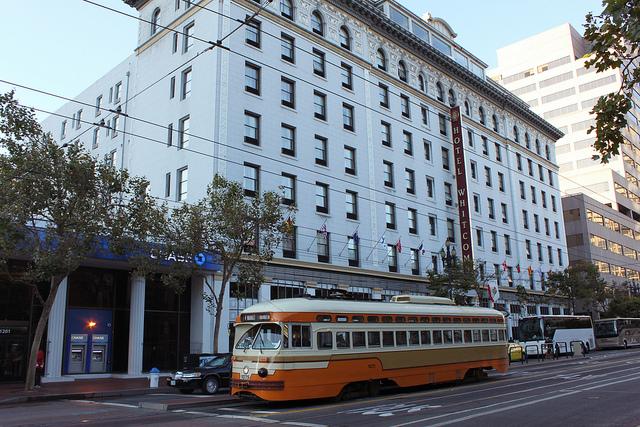How many buses are there?
Answer briefly. 3. What color is the building behind the bus?
Short answer required. White. What color is the bus?
Be succinct. Orange and white. Is the bus waiting for students?
Give a very brief answer. No. How many windows are on the side of the building?
Short answer required. 96. What is the name of the bank?
Quick response, please. Chase. 